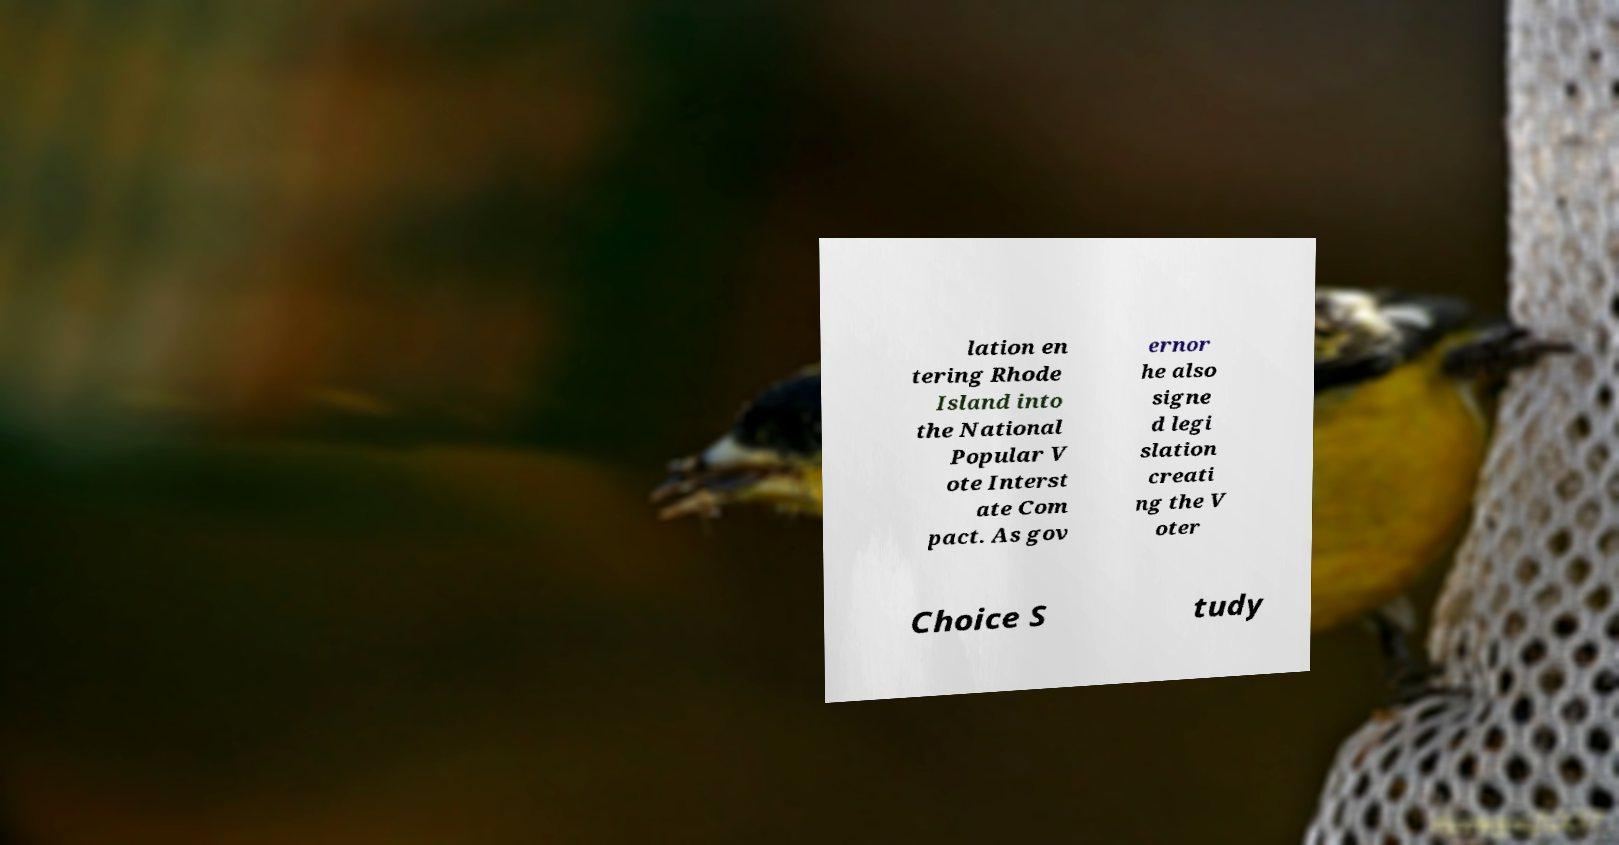Can you accurately transcribe the text from the provided image for me? lation en tering Rhode Island into the National Popular V ote Interst ate Com pact. As gov ernor he also signe d legi slation creati ng the V oter Choice S tudy 